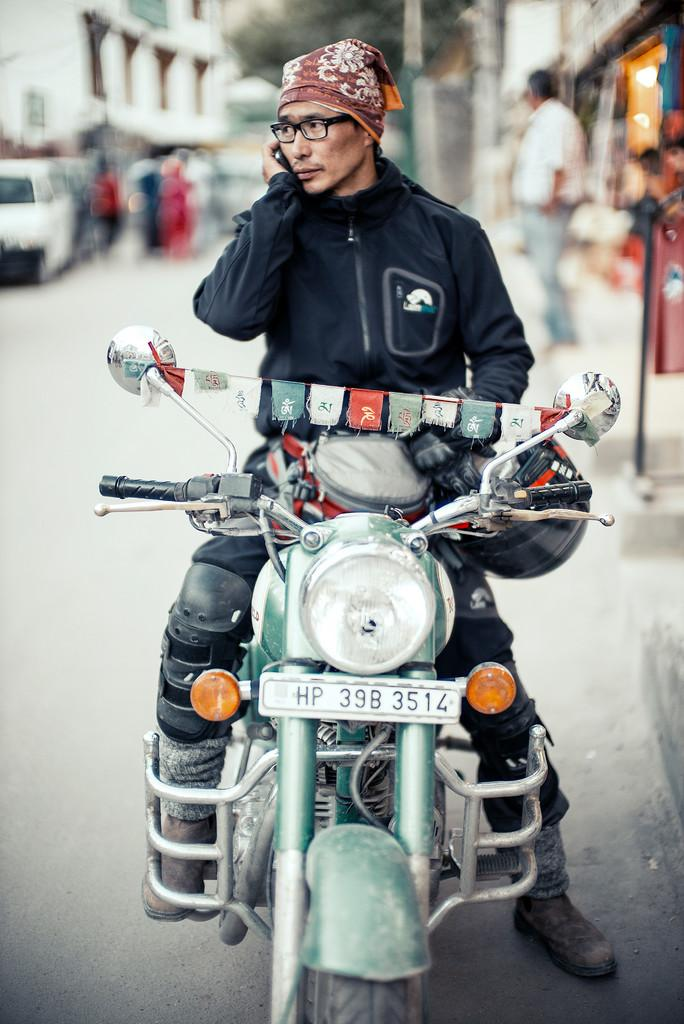What is the person in the image doing? The person is speaking on a phone. What is the person wearing in the image? The person is wearing a black jacket. Where is the person sitting in the image? The person is sitting on a Royal Enfield bike. What can be seen in the background of the image? There are cars and buildings in the background of the image. What type of bean is being cooked in the image? There is no bean present in the image. Can you see any waves in the background of the image? There are no waves visible in the image; it features a person sitting on a bike with cars and buildings in the background. 